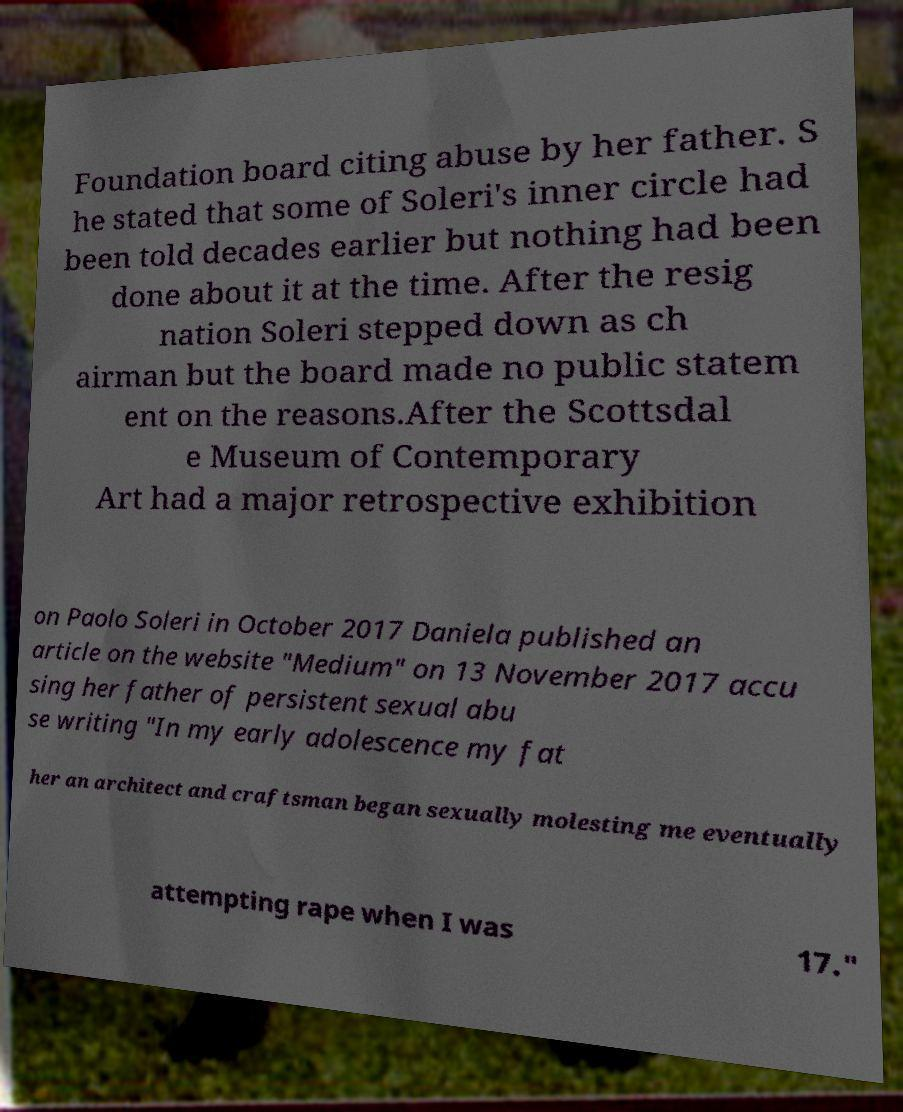There's text embedded in this image that I need extracted. Can you transcribe it verbatim? Foundation board citing abuse by her father. S he stated that some of Soleri's inner circle had been told decades earlier but nothing had been done about it at the time. After the resig nation Soleri stepped down as ch airman but the board made no public statem ent on the reasons.After the Scottsdal e Museum of Contemporary Art had a major retrospective exhibition on Paolo Soleri in October 2017 Daniela published an article on the website "Medium" on 13 November 2017 accu sing her father of persistent sexual abu se writing "In my early adolescence my fat her an architect and craftsman began sexually molesting me eventually attempting rape when I was 17." 